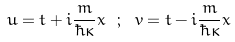Convert formula to latex. <formula><loc_0><loc_0><loc_500><loc_500>u = t + i \frac { m } { \hbar { \kappa } } x \ ; \ v = t - i \frac { m } { \hbar { \kappa } } x</formula> 